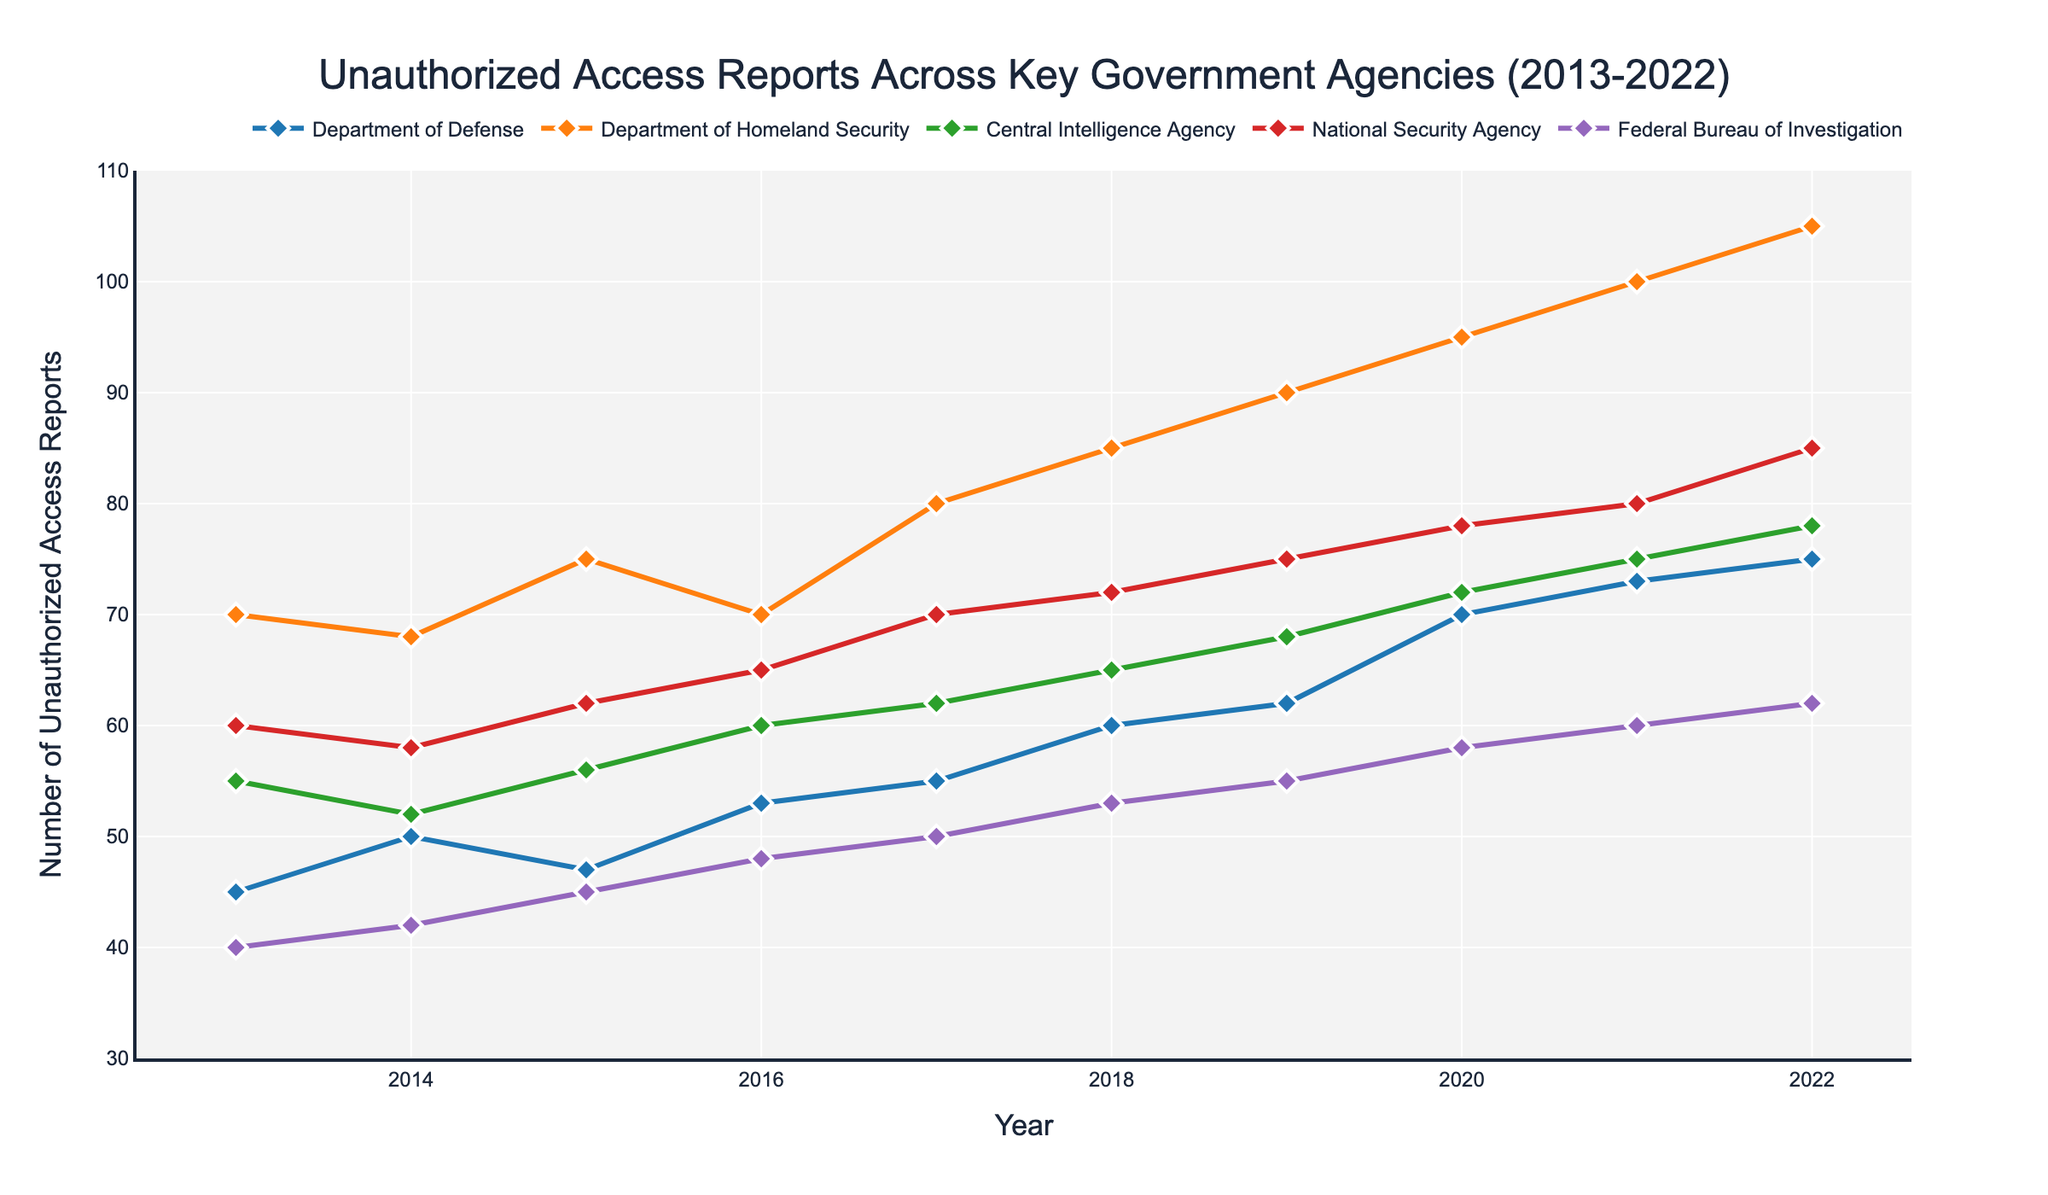How many agencies are represented in the figure? The figure shows distinct lines for each agency. Counting these lines from the legend or directly from the plot, we can see it represents five agencies.
Answer: 5 What is the range of years covered by the data in the figure? The x-axis labeled 'Year' shows the range. It starts at 2013 and ends at 2022.
Answer: 2013-2022 Which agency had the highest number of unauthorized access reports in 2016? By examining the data points for 2016, we see that the National Security Agency had the highest count at 65 reports.
Answer: National Security Agency How has the number of unauthorized access reports changed for the Department of Homeland Security (DHS) from 2013 to 2022? Observing DHS's curve, we notice it started at 70 in 2013 and increased to 105 by 2022, showing an upward trend.
Answer: Increased Which agency shows the most significant increase in unauthorized access reports over the decade? By comparing the initial and final values of each agency's curve, the Department of Homeland Security had an increase from 70 in 2013 to 105 in 2022, the largest growth of 35 reports.
Answer: Department of Homeland Security How many times did the number of reports exceed 100 for any agency? Only the Department of Homeland Security exceeded 100 reports and did so in the last two years, 2021 and 2022, giving a total count of two times.
Answer: 2 What is the total number of reports for the Federal Bureau of Investigation (FBI) in 2017 and 2020? Sum the FBI's reports for 2017 (50) and 2020 (58). Calculation is 50 + 58 = 108.
Answer: 108 Which agency has the most stable trend over the decade? By examining the trends, the Central Intelligence Agency (CIA) has the most stable line with relatively consistent values compared to the other agencies.
Answer: Central Intelligence Agency 